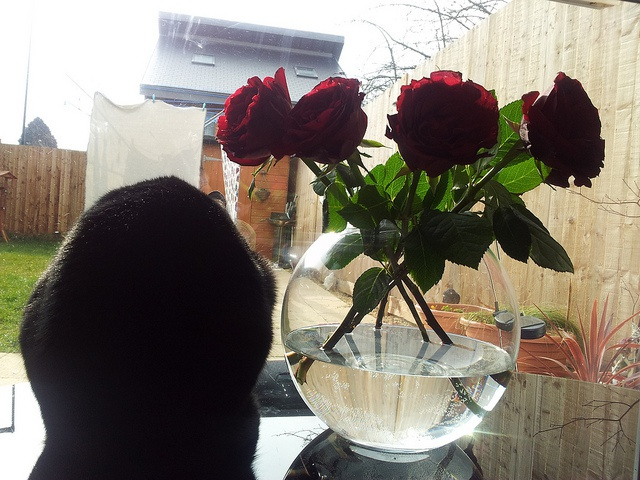Describe the objects in this image and their specific colors. I can see cat in white, black, gray, and darkgray tones, vase in white, darkgray, black, ivory, and beige tones, and potted plant in white, gray, tan, and maroon tones in this image. 